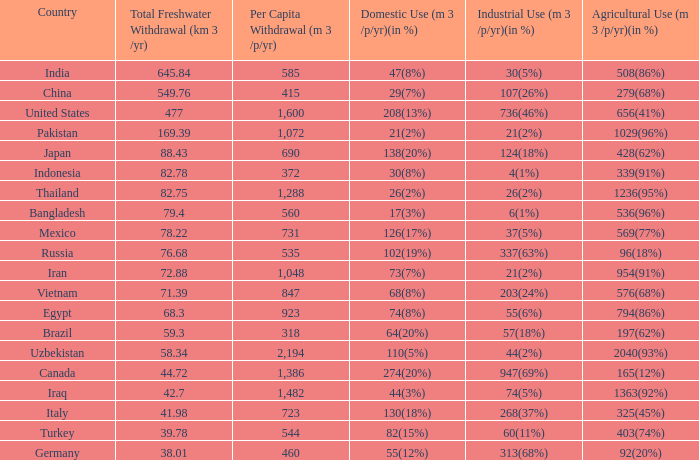What is Agricultural Use (m 3 /p/yr)(in %), when Per Capita Withdrawal (m 3 /p/yr) is greater than 923, and when Domestic Use (m 3 /p/yr)(in %) is 73(7%)? 954(91%). 